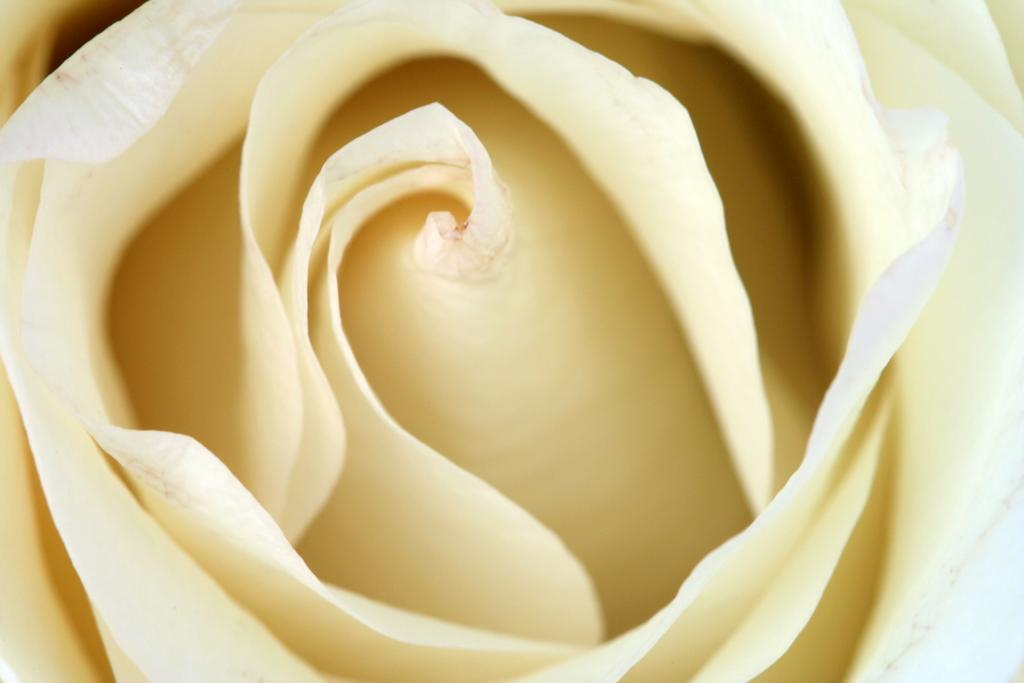What is the main subject of the image? There is a flower in the image. What type of shock can be seen coming from the flower in the image? There is no shock present in the image; it features a flower. What form of communication does the flower engage in with other flowers in the image? There are no other flowers or communication present in the image; it features a single flower. 